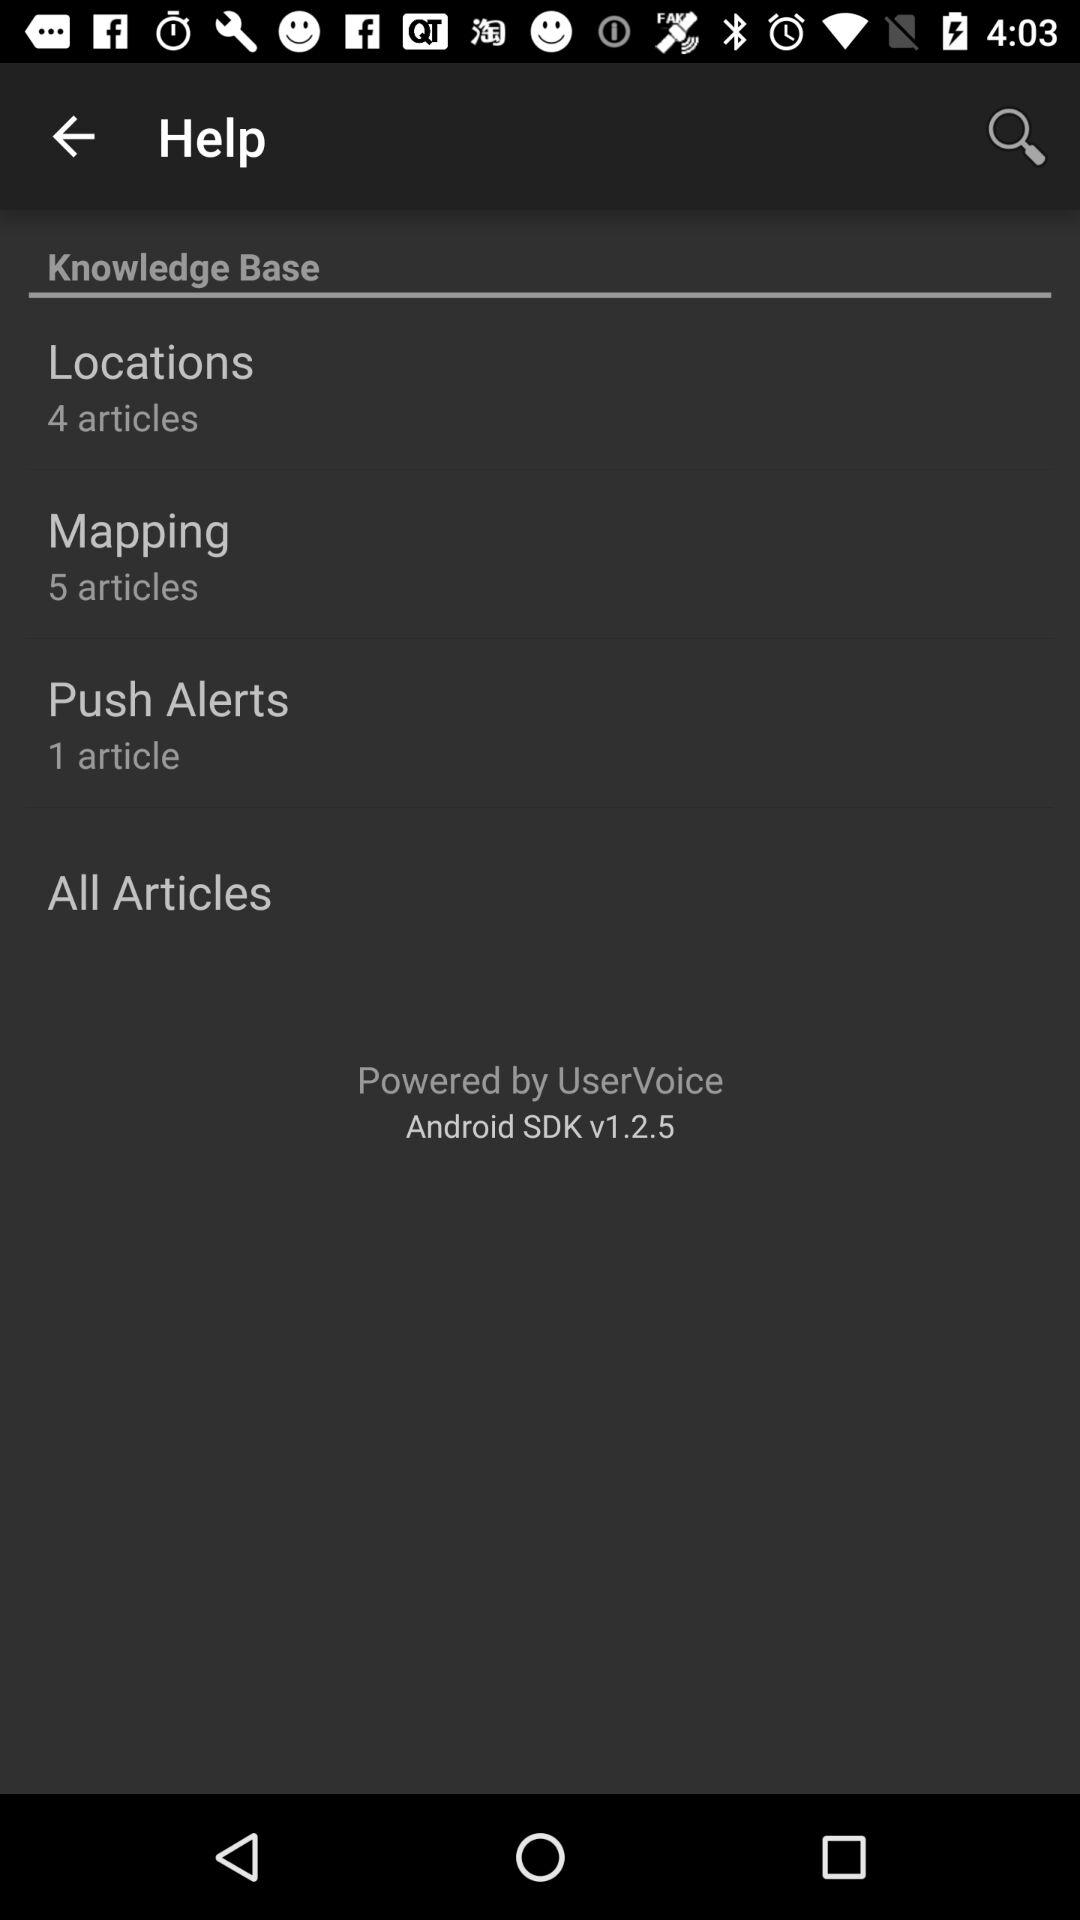How many articles are in "Push Alerts"? There is 1 article. 